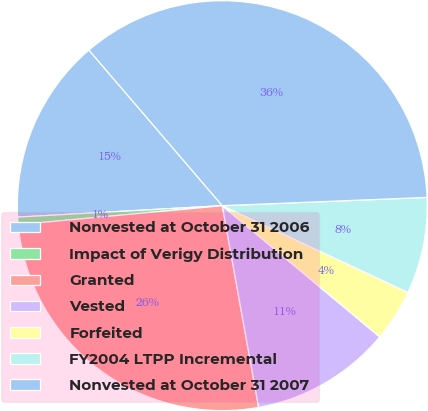<chart> <loc_0><loc_0><loc_500><loc_500><pie_chart><fcel>Nonvested at October 31 2006<fcel>Impact of Verigy Distribution<fcel>Granted<fcel>Vested<fcel>Forfeited<fcel>FY2004 LTPP Incremental<fcel>Nonvested at October 31 2007<nl><fcel>14.61%<fcel>0.59%<fcel>26.36%<fcel>11.11%<fcel>4.1%<fcel>7.6%<fcel>35.64%<nl></chart> 